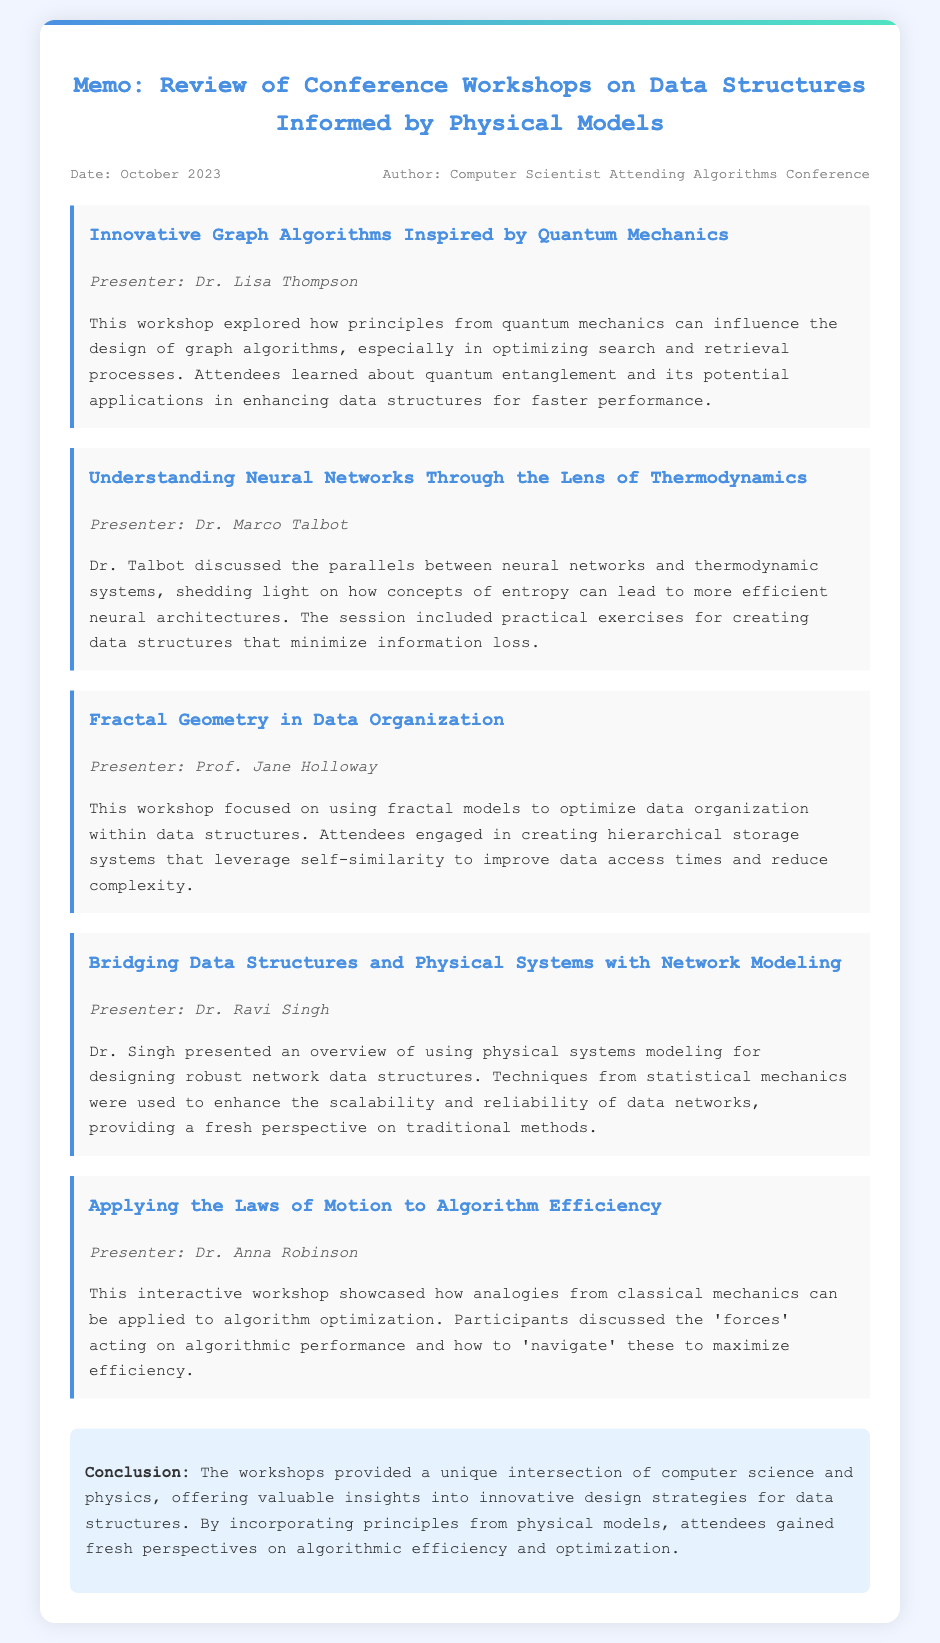What was the date of the memo? The date of the memo is stated in the meta section of the document.
Answer: October 2023 Who presented the workshop on quantum mechanics? The presenter of the quantum mechanics workshop is mentioned in the title and presenter section.
Answer: Dr. Lisa Thompson What is the focus of Dr. Marco Talbot's workshop? The focus of Dr. Talbot's workshop is described in the detailed section about his session.
Answer: Thermodynamics How many workshops are detailed in the memo? The number of workshops can be counted from the list of presented workshops in the document.
Answer: Five Which presenter discussed network modeling? This information is located in the section for Dr. Singh’s workshop.
Answer: Dr. Ravi Singh What physical concept is related to minimizing information loss? The memo explicitly states the concepts linked to Dr. Talbot's workshop.
Answer: Entropy What innovative approach is used in the fractal geometry workshop? The memo contains an explanation of the approach used in the fractal geometry workshop.
Answer: Hierarchical storage systems What overarching theme ties all the workshops together? The conclusion provides insights into the connection among the workshops.
Answer: Physical models What is the final takeaway from the workshops, according to the memo? The conclusion summarizes the main insight gained from the workshops.
Answer: Innovative design strategies 